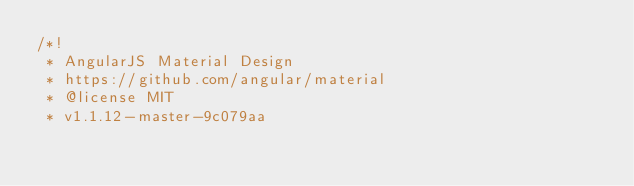Convert code to text. <code><loc_0><loc_0><loc_500><loc_500><_CSS_>/*!
 * AngularJS Material Design
 * https://github.com/angular/material
 * @license MIT
 * v1.1.12-master-9c079aa</code> 